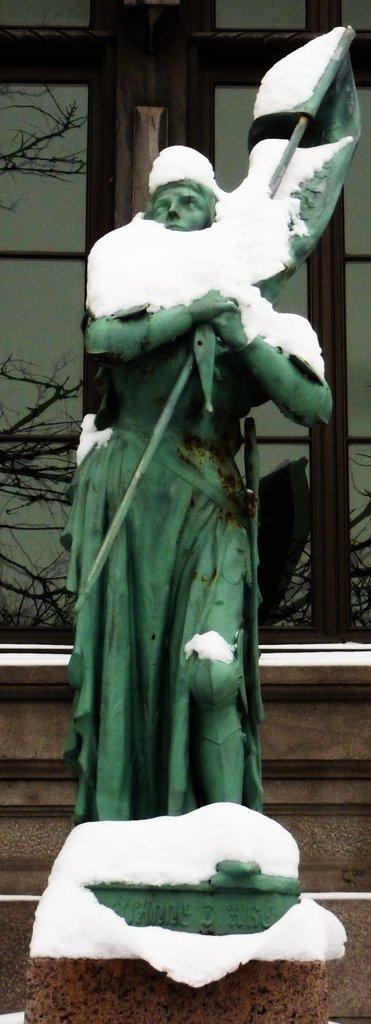What is the main subject of the image? There is a sculpture of a person in the image. What is covering the sculpture? The sculpture has snow on it. What can be seen in the background of the image? There are trees and other objects visible in the background of the image. What type of stage is visible in the image? There is no stage present in the image; it features a sculpture of a person with snow on it and a background with trees and other objects. What color is the quartz used to create the sculpture? There is no mention of quartz being used to create the sculpture, and the material used is not specified in the image. 